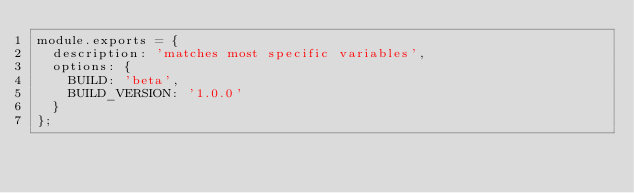<code> <loc_0><loc_0><loc_500><loc_500><_JavaScript_>module.exports = {
  description: 'matches most specific variables',
  options: {
    BUILD: 'beta',
    BUILD_VERSION: '1.0.0'
  }
};
</code> 